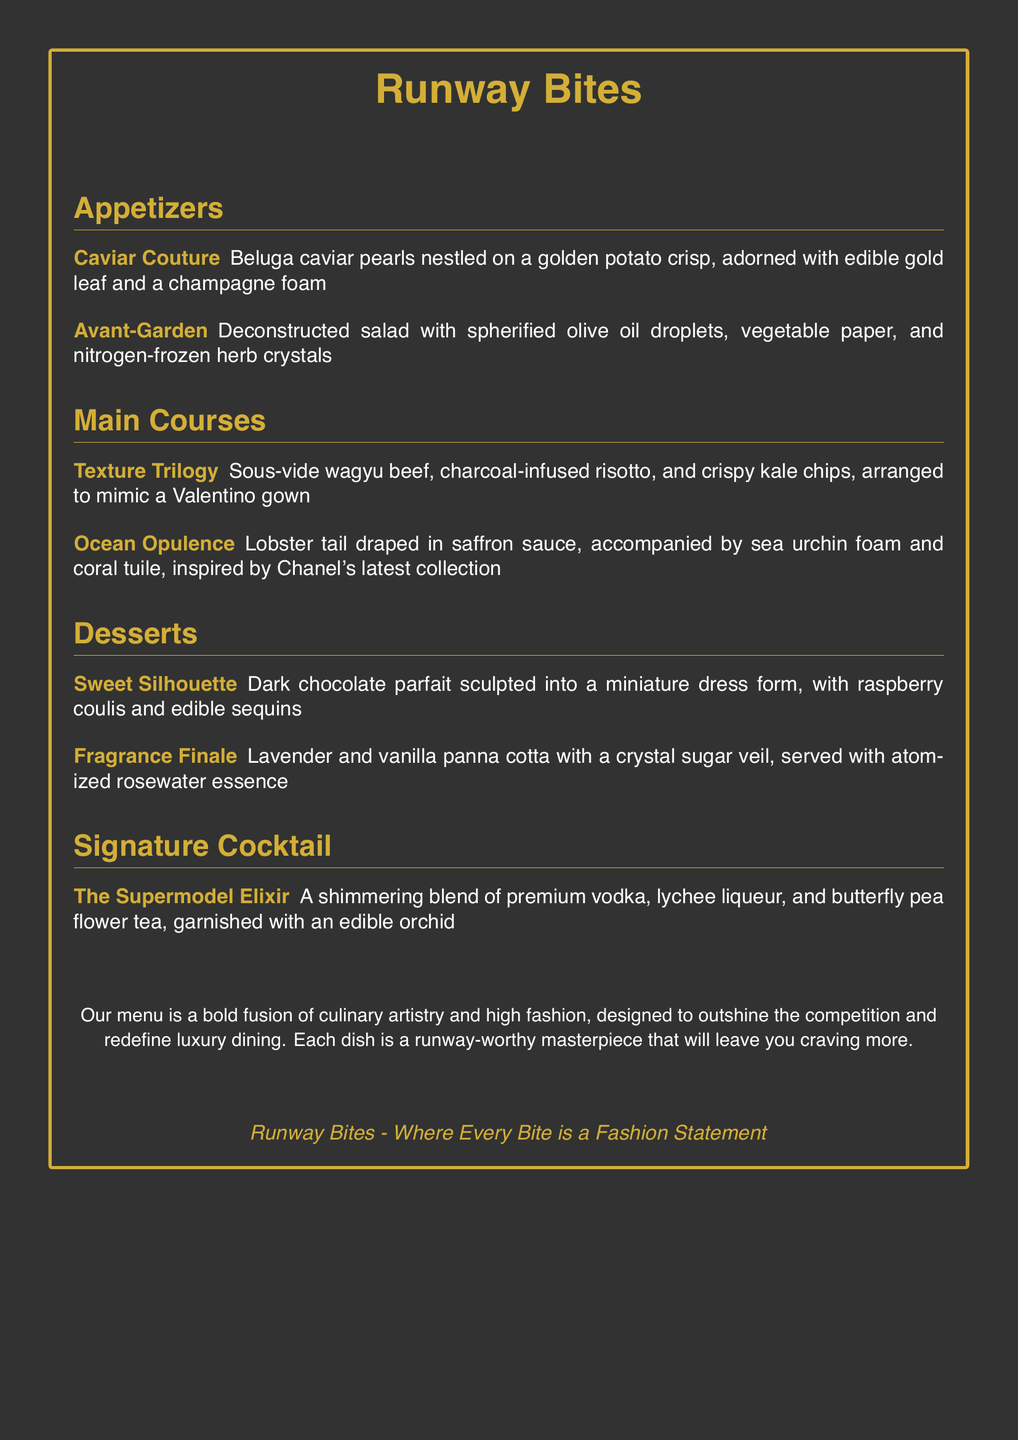What is the name of the signature cocktail? The signature cocktail is specifically named in the menu section under "Signature Cocktail".
Answer: The Supermodel Elixir How many appetizers are listed? The appetizers section contains two distinct dishes, as listed in the document.
Answer: 2 What is the main ingredient in the dish "Ocean Opulence"? The dish "Ocean Opulence" prominently features lobster tail as its main ingredient.
Answer: Lobster tail Which dessert is described as a miniature dress form? The dessert "Sweet Silhouette" is specifically sculpted into the form of a miniature dress, as detailed in the menu.
Answer: Sweet Silhouette What unique ingredient is used in the cocktail? The cocktail includes butterfly pea flower tea, a distinctive component highlighted in the description.
Answer: Butterfly pea flower tea What fashion house inspired the "Ocean Opulence" dish? The inspiration for the "Ocean Opulence" dish is explicitly credited to the fashion house mentioned in the menu.
Answer: Chanel What visual element is included with the "Caviar Couture"? The menu notes the inclusion of edible gold leaf as a decorative visual element in the "Caviar Couture" dish.
Answer: Edible gold leaf Which dessert features atomized rosewater essence? The dessert described to include atomized rosewater essence is mentioned in the concluding section of the dessert items.
Answer: Fragrance Finale What is the color of the menu's page background? The color of the background page is clearly defined in the document's formatting and visual styling.
Answer: Dark gray 